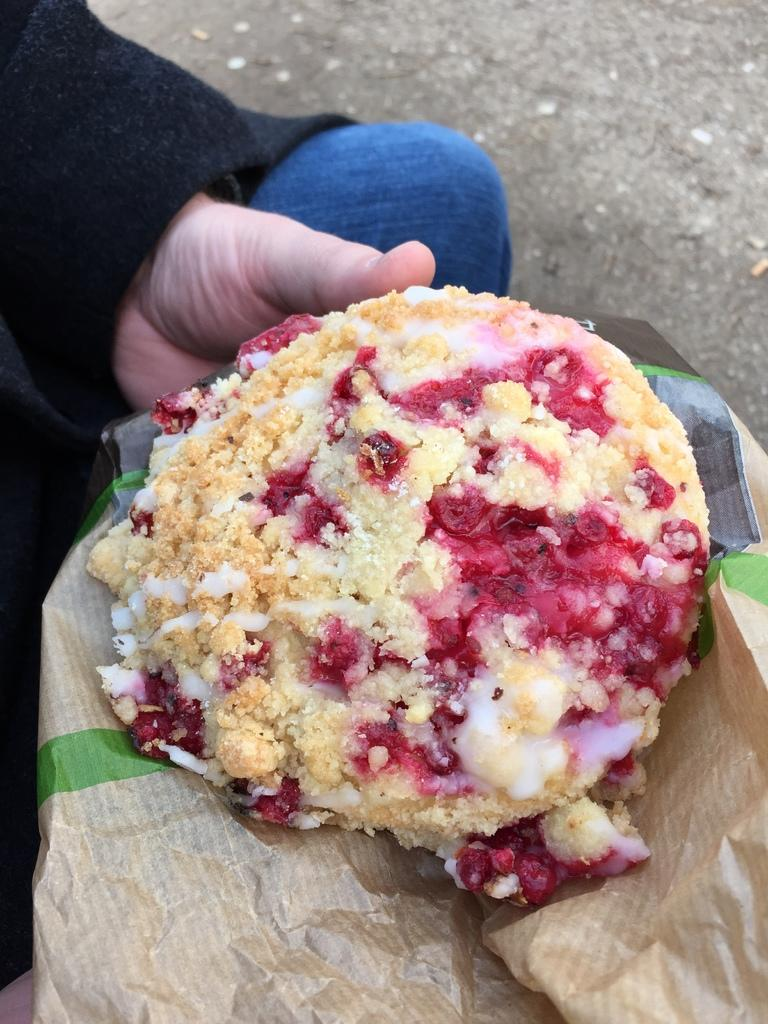What is present in the image? There is a person in the image. What is the person doing in the image? The person is holding food in their hand. Can you describe the time of day when the image was taken? The image was taken during the day. Where is the cemetery located in the image? There is no cemetery present in the image. What type of furniture can be seen in the image? There is no furniture present in the image. 